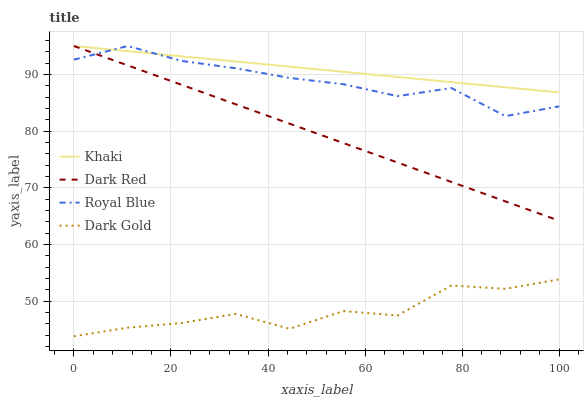Does Khaki have the minimum area under the curve?
Answer yes or no. No. Does Dark Gold have the maximum area under the curve?
Answer yes or no. No. Is Khaki the smoothest?
Answer yes or no. No. Is Khaki the roughest?
Answer yes or no. No. Does Khaki have the lowest value?
Answer yes or no. No. Does Dark Gold have the highest value?
Answer yes or no. No. Is Dark Gold less than Dark Red?
Answer yes or no. Yes. Is Royal Blue greater than Dark Gold?
Answer yes or no. Yes. Does Dark Gold intersect Dark Red?
Answer yes or no. No. 